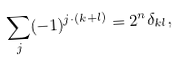<formula> <loc_0><loc_0><loc_500><loc_500>\sum _ { j } ( - 1 ) ^ { j \cdot ( k + l ) } = 2 ^ { n } \delta _ { k l } ,</formula> 